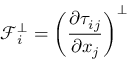<formula> <loc_0><loc_0><loc_500><loc_500>\mathcal { F } _ { i } ^ { \bot } = \left ( \frac { \partial \tau _ { i j } } { \partial x _ { j } } \right ) ^ { \bot }</formula> 